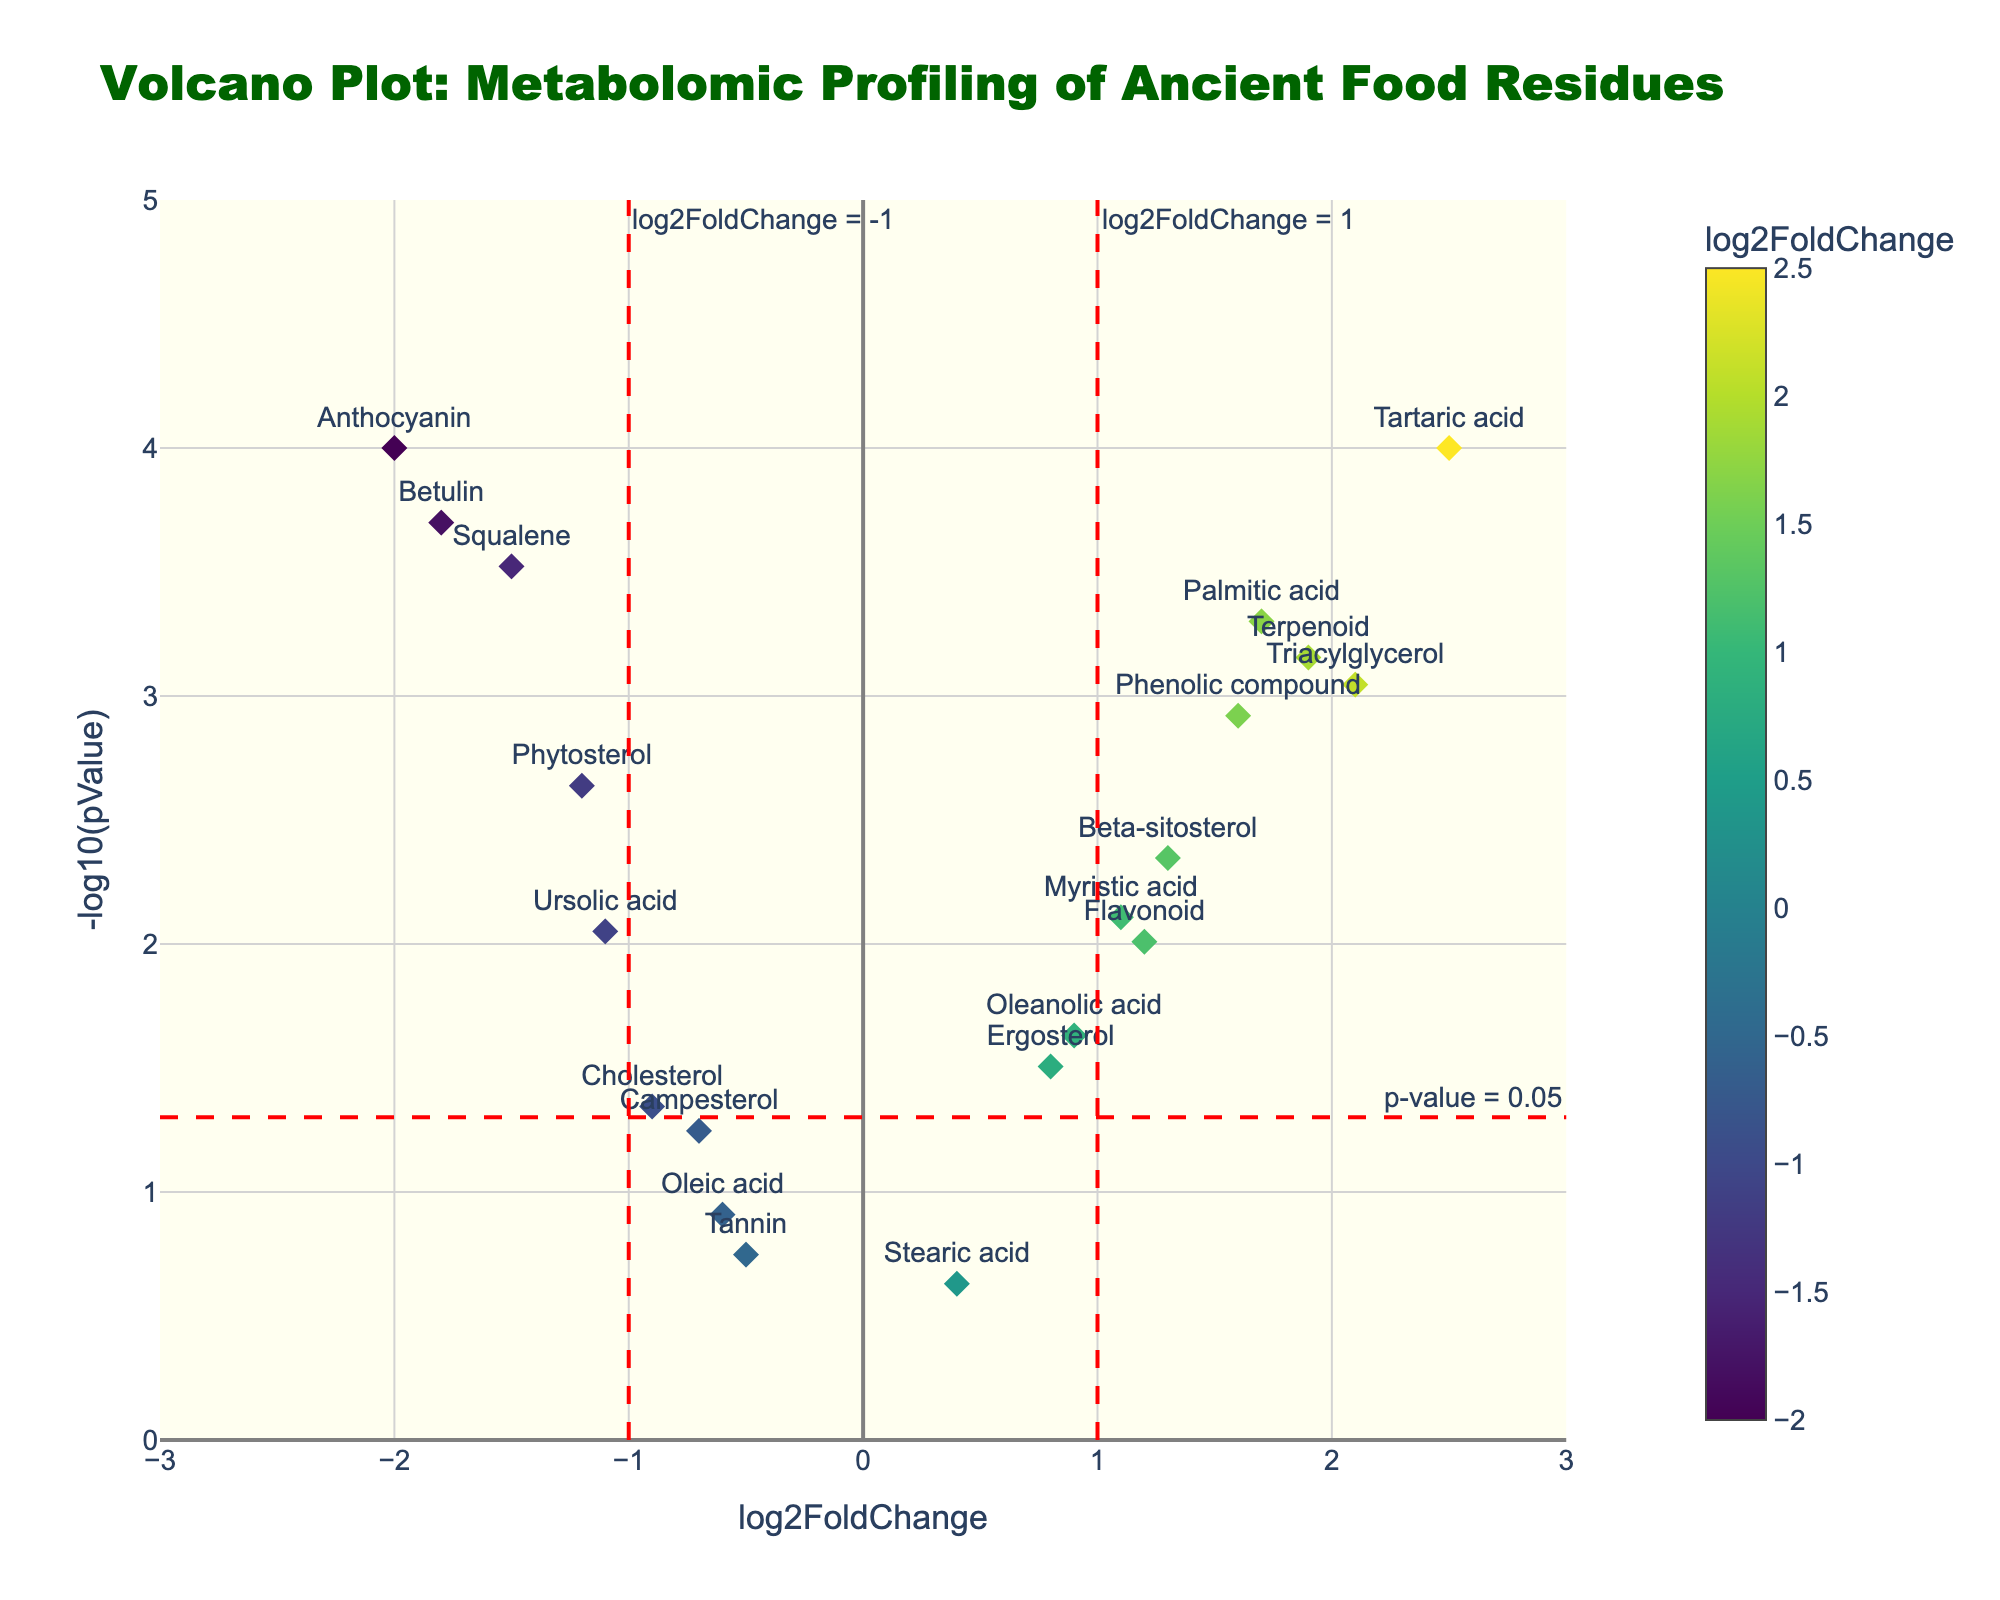Which compound has the highest -log10(pValue) in the plot? To answer this, look at the highest point on the y-axis (-log10(pValue)). The compound with the highest y-value is "Tartaric acid".
Answer: Tartaric acid What does the red horizontal line signify in the plot? The red horizontal line is labeled "p-value = 0.05", indicating the threshold for statistical significance. Compounds above this line are statistically significant.
Answer: p-value = 0.05 How many compounds have a log2FoldChange greater than 1? Count the data points to the right of the red vertical line at x=1. These compounds are "Tartaric acid", "Palmitic acid", "Triacylglycerol", "Beta-sitosterol", "Terpenoid".
Answer: 5 Which compound has the most negative log2FoldChange value in the plot? Locate the point furthest to the left on the x-axis (log2FoldChange). The compound with the most negative value is "Anthocyanin".
Answer: Anthocyanin What are the colors indicating in the plot? Examine the color scale, which is labeled with "log2FoldChange". It shows that varying colors represent different log2FoldChange values, with a color gradient (Viridis colorscale).
Answer: log2FoldChange values Which compound falls near the intersection of the vertical and horizontal red dashed lines? Identify the point nearest to the intersection of x=1 and y=-log10(0.05). "Palmitic acid" is closest to this intersection.
Answer: Palmitic acid What does a positive log2FoldChange signify on this plot? A positive log2FoldChange indicates an increase in the compound's abundance in the experimental condition compared to the control condition.
Answer: Increase in abundance Which compounds have a log2FoldChange value less than -1 and are also statistically significant (p < 0.05)? Look for compounds left of the red vertical line at x=-1 and above the horizontal line y=-log10(0.05): "Betulin", "Squalene", "Ursolic acid", "Anthocyanin".
Answer: Betulin, Squalene, Ursolic acid, Anthocyanin Are there any compounds with a log2FoldChange near zero and statistically insignificant (p > 0.05)? Identify compounds near x=0 and below y=-log10(0.05). "Stearic acid" fits this description.
Answer: Stearic acid 